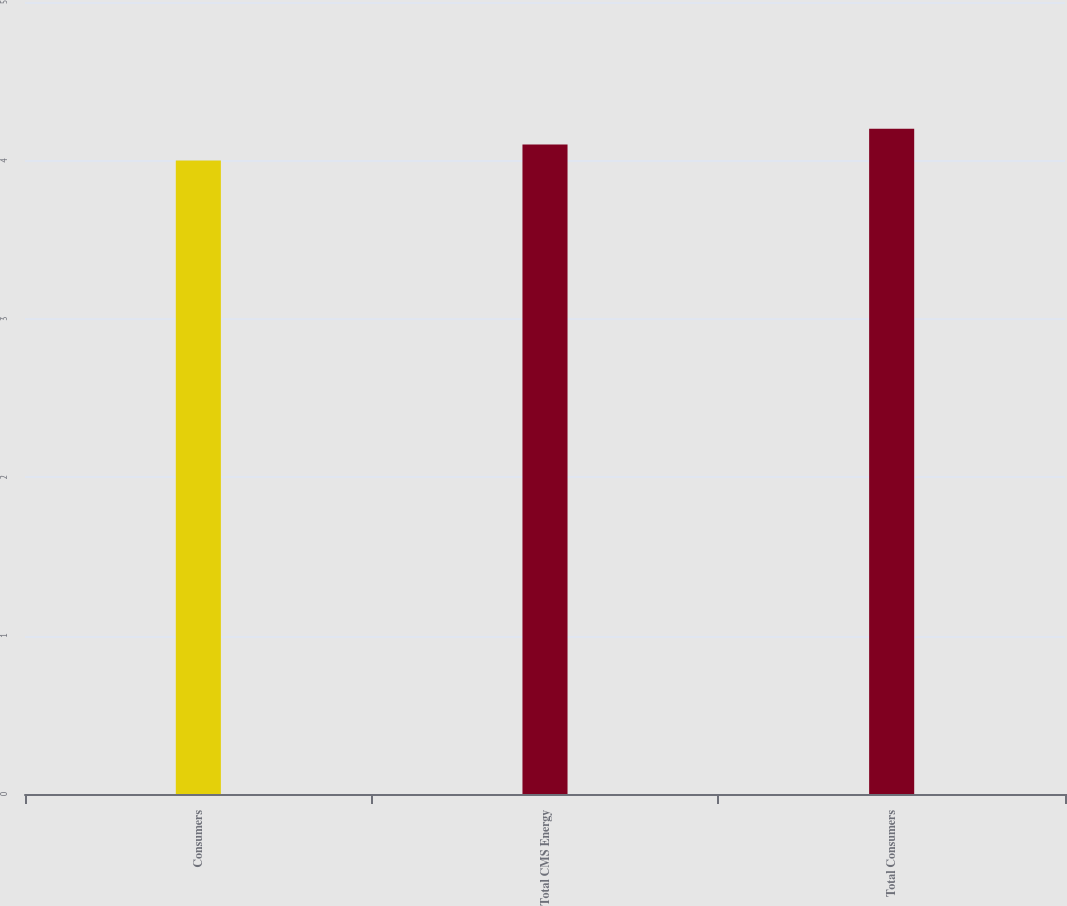Convert chart. <chart><loc_0><loc_0><loc_500><loc_500><bar_chart><fcel>Consumers<fcel>Total CMS Energy<fcel>Total Consumers<nl><fcel>4<fcel>4.1<fcel>4.2<nl></chart> 